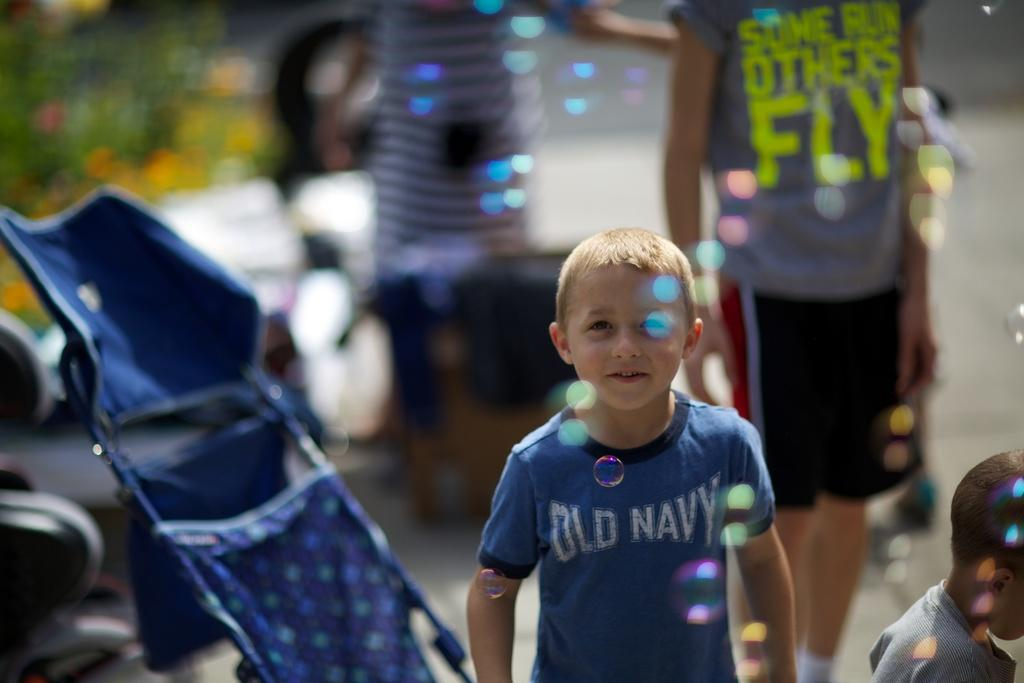What is the main subject of the image? There is a boy standing in the image. What object is present near the boy? There is a stroller in the image. Are there any other people in the image besides the boy? Yes, there is a group of people standing in the image. Can you describe the background of the image? The background of the image is blurred. What type of street can be seen in the background of the image? There is no street visible in the image, as the background is blurred. Can you tell me how many elbows are visible in the image? The number of elbows cannot be determined from the image, as it only shows a boy, a stroller, and a group of people without specific details about their body parts. 